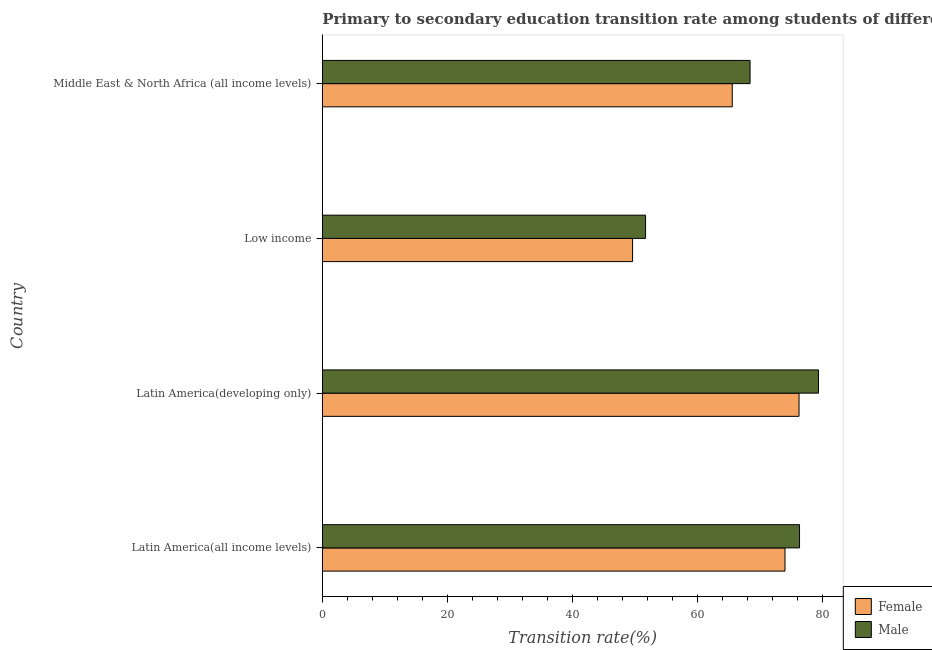How many different coloured bars are there?
Offer a very short reply. 2. Are the number of bars per tick equal to the number of legend labels?
Provide a succinct answer. Yes. How many bars are there on the 1st tick from the top?
Offer a very short reply. 2. What is the label of the 1st group of bars from the top?
Offer a very short reply. Middle East & North Africa (all income levels). In how many cases, is the number of bars for a given country not equal to the number of legend labels?
Keep it short and to the point. 0. What is the transition rate among male students in Middle East & North Africa (all income levels)?
Keep it short and to the point. 68.45. Across all countries, what is the maximum transition rate among male students?
Ensure brevity in your answer.  79.4. Across all countries, what is the minimum transition rate among male students?
Your answer should be compact. 51.72. In which country was the transition rate among male students maximum?
Your response must be concise. Latin America(developing only). In which country was the transition rate among male students minimum?
Give a very brief answer. Low income. What is the total transition rate among female students in the graph?
Keep it short and to the point. 265.56. What is the difference between the transition rate among female students in Latin America(developing only) and that in Middle East & North Africa (all income levels)?
Offer a very short reply. 10.69. What is the difference between the transition rate among female students in Middle East & North Africa (all income levels) and the transition rate among male students in Low income?
Make the answer very short. 13.87. What is the average transition rate among female students per country?
Provide a short and direct response. 66.39. What is the difference between the transition rate among female students and transition rate among male students in Middle East & North Africa (all income levels)?
Give a very brief answer. -2.85. What is the ratio of the transition rate among male students in Latin America(all income levels) to that in Low income?
Ensure brevity in your answer.  1.48. Is the transition rate among female students in Low income less than that in Middle East & North Africa (all income levels)?
Ensure brevity in your answer.  Yes. What is the difference between the highest and the second highest transition rate among male students?
Offer a terse response. 3.04. What is the difference between the highest and the lowest transition rate among male students?
Give a very brief answer. 27.67. In how many countries, is the transition rate among female students greater than the average transition rate among female students taken over all countries?
Offer a terse response. 2. What does the 1st bar from the bottom in Latin America(all income levels) represents?
Ensure brevity in your answer.  Female. How many bars are there?
Make the answer very short. 8. What is the difference between two consecutive major ticks on the X-axis?
Provide a succinct answer. 20. Are the values on the major ticks of X-axis written in scientific E-notation?
Offer a terse response. No. Does the graph contain any zero values?
Give a very brief answer. No. How many legend labels are there?
Provide a succinct answer. 2. What is the title of the graph?
Provide a succinct answer. Primary to secondary education transition rate among students of different countries. Does "Age 65(female)" appear as one of the legend labels in the graph?
Provide a succinct answer. No. What is the label or title of the X-axis?
Offer a terse response. Transition rate(%). What is the label or title of the Y-axis?
Your answer should be compact. Country. What is the Transition rate(%) in Female in Latin America(all income levels)?
Make the answer very short. 74.04. What is the Transition rate(%) of Male in Latin America(all income levels)?
Make the answer very short. 76.36. What is the Transition rate(%) in Female in Latin America(developing only)?
Your answer should be very brief. 76.28. What is the Transition rate(%) in Male in Latin America(developing only)?
Your answer should be compact. 79.4. What is the Transition rate(%) in Female in Low income?
Your answer should be very brief. 49.65. What is the Transition rate(%) of Male in Low income?
Your answer should be compact. 51.72. What is the Transition rate(%) in Female in Middle East & North Africa (all income levels)?
Provide a succinct answer. 65.6. What is the Transition rate(%) in Male in Middle East & North Africa (all income levels)?
Keep it short and to the point. 68.45. Across all countries, what is the maximum Transition rate(%) of Female?
Ensure brevity in your answer.  76.28. Across all countries, what is the maximum Transition rate(%) of Male?
Your response must be concise. 79.4. Across all countries, what is the minimum Transition rate(%) of Female?
Provide a short and direct response. 49.65. Across all countries, what is the minimum Transition rate(%) of Male?
Offer a very short reply. 51.72. What is the total Transition rate(%) of Female in the graph?
Provide a short and direct response. 265.56. What is the total Transition rate(%) in Male in the graph?
Your response must be concise. 275.92. What is the difference between the Transition rate(%) of Female in Latin America(all income levels) and that in Latin America(developing only)?
Make the answer very short. -2.24. What is the difference between the Transition rate(%) in Male in Latin America(all income levels) and that in Latin America(developing only)?
Ensure brevity in your answer.  -3.04. What is the difference between the Transition rate(%) of Female in Latin America(all income levels) and that in Low income?
Offer a terse response. 24.39. What is the difference between the Transition rate(%) of Male in Latin America(all income levels) and that in Low income?
Provide a succinct answer. 24.64. What is the difference between the Transition rate(%) in Female in Latin America(all income levels) and that in Middle East & North Africa (all income levels)?
Your answer should be compact. 8.44. What is the difference between the Transition rate(%) of Male in Latin America(all income levels) and that in Middle East & North Africa (all income levels)?
Your answer should be very brief. 7.92. What is the difference between the Transition rate(%) of Female in Latin America(developing only) and that in Low income?
Your answer should be very brief. 26.64. What is the difference between the Transition rate(%) in Male in Latin America(developing only) and that in Low income?
Provide a short and direct response. 27.67. What is the difference between the Transition rate(%) of Female in Latin America(developing only) and that in Middle East & North Africa (all income levels)?
Offer a terse response. 10.69. What is the difference between the Transition rate(%) in Male in Latin America(developing only) and that in Middle East & North Africa (all income levels)?
Keep it short and to the point. 10.95. What is the difference between the Transition rate(%) of Female in Low income and that in Middle East & North Africa (all income levels)?
Your answer should be very brief. -15.95. What is the difference between the Transition rate(%) of Male in Low income and that in Middle East & North Africa (all income levels)?
Your answer should be very brief. -16.72. What is the difference between the Transition rate(%) in Female in Latin America(all income levels) and the Transition rate(%) in Male in Latin America(developing only)?
Your answer should be very brief. -5.36. What is the difference between the Transition rate(%) in Female in Latin America(all income levels) and the Transition rate(%) in Male in Low income?
Make the answer very short. 22.31. What is the difference between the Transition rate(%) of Female in Latin America(all income levels) and the Transition rate(%) of Male in Middle East & North Africa (all income levels)?
Your answer should be very brief. 5.59. What is the difference between the Transition rate(%) of Female in Latin America(developing only) and the Transition rate(%) of Male in Low income?
Offer a terse response. 24.56. What is the difference between the Transition rate(%) in Female in Latin America(developing only) and the Transition rate(%) in Male in Middle East & North Africa (all income levels)?
Provide a short and direct response. 7.84. What is the difference between the Transition rate(%) of Female in Low income and the Transition rate(%) of Male in Middle East & North Africa (all income levels)?
Ensure brevity in your answer.  -18.8. What is the average Transition rate(%) in Female per country?
Ensure brevity in your answer.  66.39. What is the average Transition rate(%) of Male per country?
Give a very brief answer. 68.98. What is the difference between the Transition rate(%) of Female and Transition rate(%) of Male in Latin America(all income levels)?
Make the answer very short. -2.32. What is the difference between the Transition rate(%) in Female and Transition rate(%) in Male in Latin America(developing only)?
Your answer should be compact. -3.11. What is the difference between the Transition rate(%) in Female and Transition rate(%) in Male in Low income?
Keep it short and to the point. -2.08. What is the difference between the Transition rate(%) of Female and Transition rate(%) of Male in Middle East & North Africa (all income levels)?
Your response must be concise. -2.85. What is the ratio of the Transition rate(%) in Female in Latin America(all income levels) to that in Latin America(developing only)?
Your response must be concise. 0.97. What is the ratio of the Transition rate(%) in Male in Latin America(all income levels) to that in Latin America(developing only)?
Ensure brevity in your answer.  0.96. What is the ratio of the Transition rate(%) of Female in Latin America(all income levels) to that in Low income?
Provide a short and direct response. 1.49. What is the ratio of the Transition rate(%) of Male in Latin America(all income levels) to that in Low income?
Your answer should be compact. 1.48. What is the ratio of the Transition rate(%) of Female in Latin America(all income levels) to that in Middle East & North Africa (all income levels)?
Ensure brevity in your answer.  1.13. What is the ratio of the Transition rate(%) of Male in Latin America(all income levels) to that in Middle East & North Africa (all income levels)?
Provide a succinct answer. 1.12. What is the ratio of the Transition rate(%) of Female in Latin America(developing only) to that in Low income?
Your response must be concise. 1.54. What is the ratio of the Transition rate(%) in Male in Latin America(developing only) to that in Low income?
Ensure brevity in your answer.  1.53. What is the ratio of the Transition rate(%) in Female in Latin America(developing only) to that in Middle East & North Africa (all income levels)?
Your answer should be compact. 1.16. What is the ratio of the Transition rate(%) in Male in Latin America(developing only) to that in Middle East & North Africa (all income levels)?
Your answer should be compact. 1.16. What is the ratio of the Transition rate(%) of Female in Low income to that in Middle East & North Africa (all income levels)?
Make the answer very short. 0.76. What is the ratio of the Transition rate(%) in Male in Low income to that in Middle East & North Africa (all income levels)?
Make the answer very short. 0.76. What is the difference between the highest and the second highest Transition rate(%) of Female?
Ensure brevity in your answer.  2.24. What is the difference between the highest and the second highest Transition rate(%) of Male?
Provide a short and direct response. 3.04. What is the difference between the highest and the lowest Transition rate(%) of Female?
Offer a very short reply. 26.64. What is the difference between the highest and the lowest Transition rate(%) in Male?
Keep it short and to the point. 27.67. 